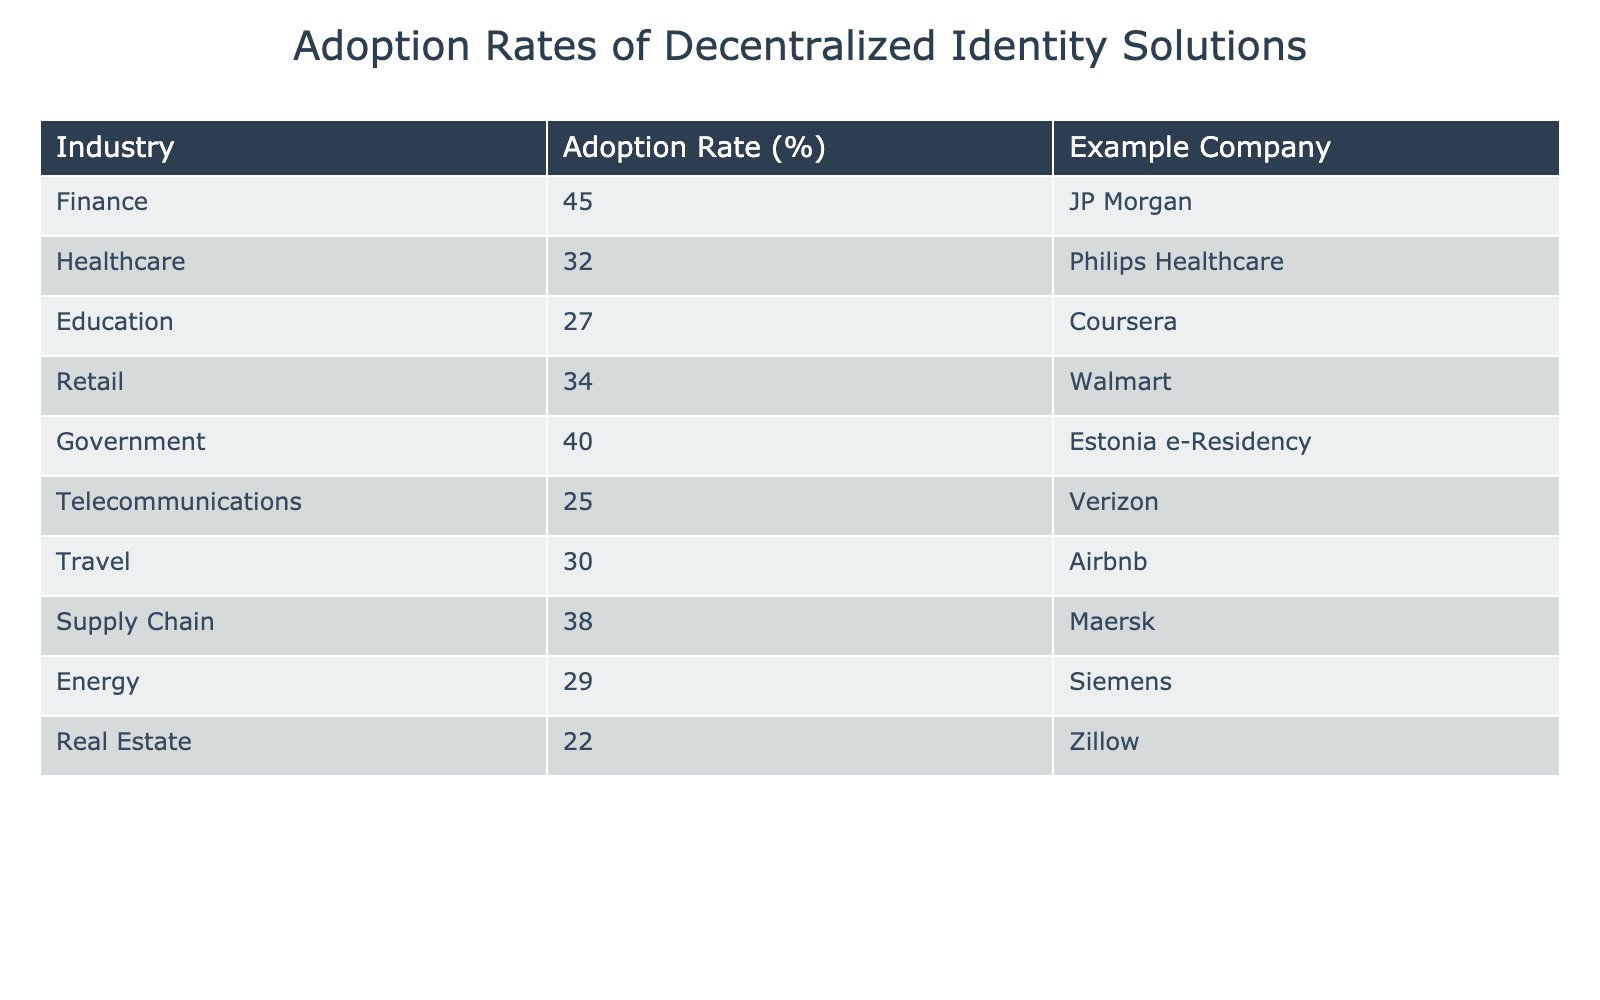What is the adoption rate of decentralized identity solutions in the Finance industry? The adoption rate for the Finance industry is directly provided in the table under the "Adoption Rate (%)" column for the Finance row. The value listed is 45.
Answer: 45 Which industry has the lowest adoption rate? To find the lowest adoption rate, we analyze the adoption rates across all industries. From the given values, Real Estate has the lowest value at 22%.
Answer: 22 What is the average adoption rate across all listed industries? The adoption rates are 45, 32, 27, 34, 40, 25, 30, 38, 29, and 22. We sum these values to get  45 + 32 + 27 + 34 + 40 + 25 + 30 + 38 + 29 + 22 =  352. There are 10 values, so the average is 352 / 10 = 35.2.
Answer: 35.2 Is it true that the Healthcare industry has a higher adoption rate than the Education industry? The adoption rate for Healthcare is 32%, while for Education, it is 27%. Since 32 is greater than 27, the statement is true.
Answer: Yes Which two industries have an adoption rate above 35%? We check the adoption rates one by one: Finance (45%), Government (40%), and Supply Chain (38%) all exceed 35%. Thus, Finance, Government, and Supply Chain have rates above 35%. The two most notable ones, however, are Finance and Government.
Answer: Finance and Government Which industry has a higher adoption rate: Telecommunications or Energy? The adoption rate for Telecommunications is 25%, and for Energy, it is 29%. Comparing the two rates, Energy has a higher rate than Telecommunications.
Answer: Energy What is the difference in adoption rates between the highest (Finance) and the lowest (Real Estate) industries? The highest adoption rate is 45% for Finance and the lowest is 22% for Real Estate. The difference is calculated by subtracting the lowest from the highest: 45 - 22 = 23.
Answer: 23 Are there more industries with an adoption rate above 30% than below 30%? We list the rates: Above 30%: Finance (45%), Healthcare (32%), Retail (34%), Government (40%), and Supply Chain (38%) - totaling 5. Below 30%: Telecommunications (25%), Travel (30), and Real Estate (22%) - totaling 4. Therefore, there are more above 30%.
Answer: Yes 